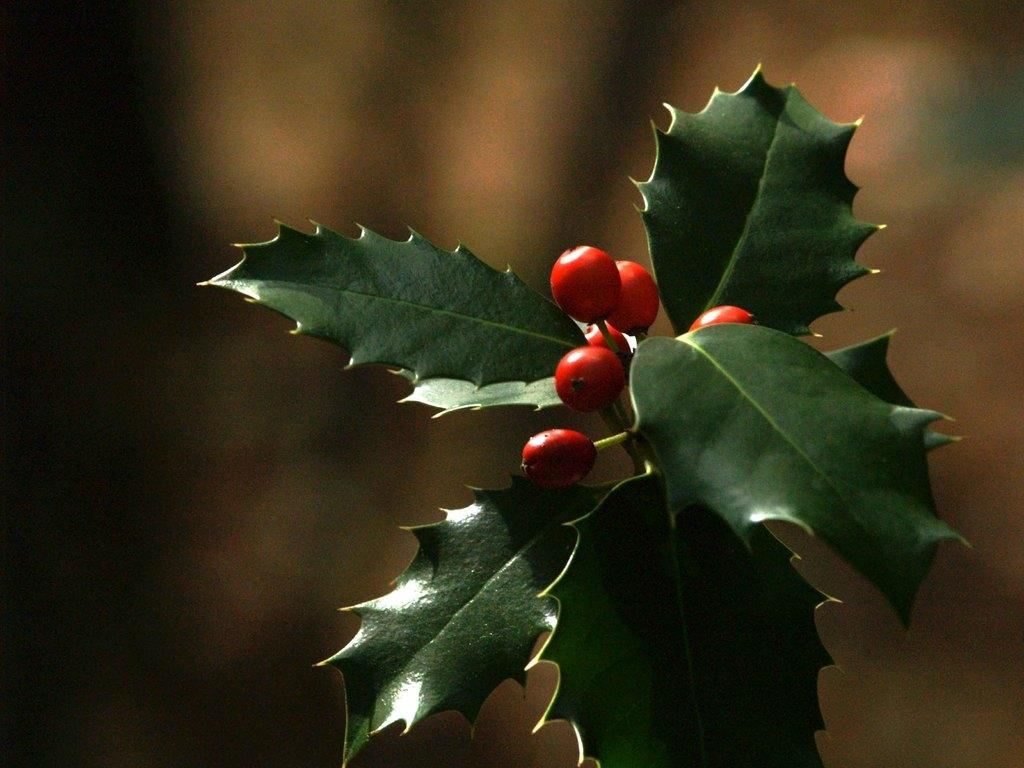What is present in the picture? There is a plant in the picture. What can be observed about the plant? The plant has fruits and leaves. What is the color of the fruits on the plant? The fruits are red in color. What type of water can be seen in the can or jar in the image? There is no can or jar with water present in the image; it features a plant with red fruits. 